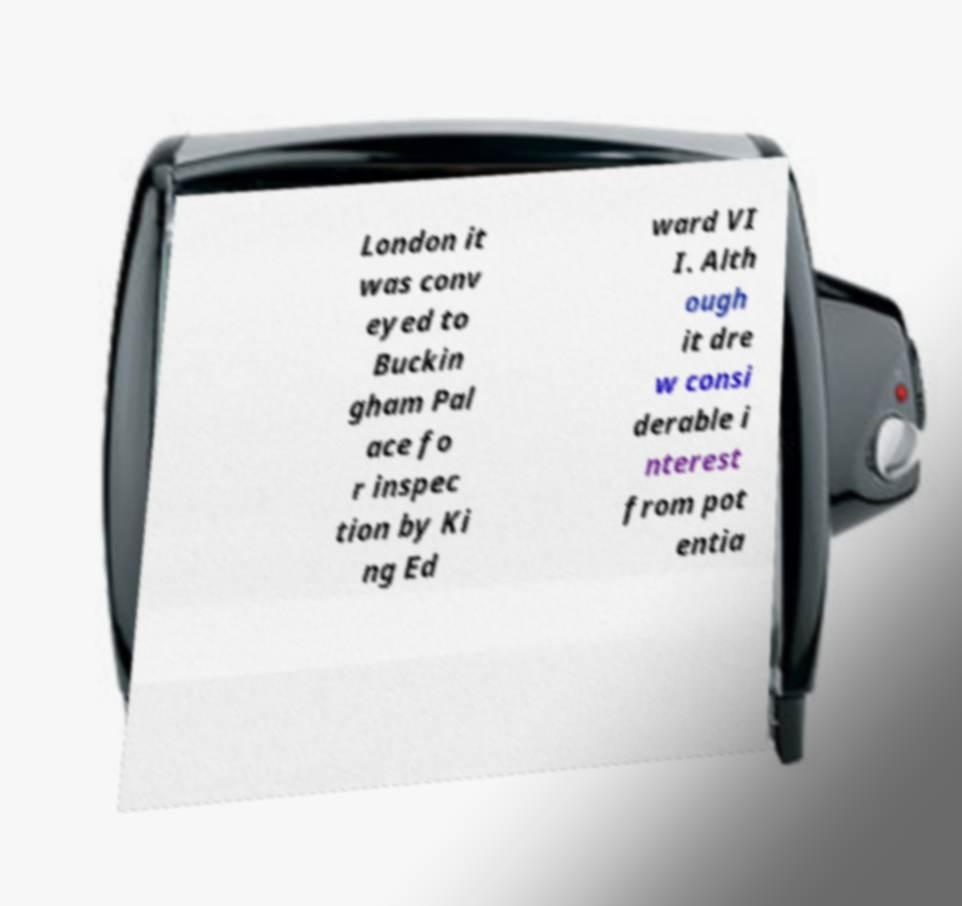Please read and relay the text visible in this image. What does it say? London it was conv eyed to Buckin gham Pal ace fo r inspec tion by Ki ng Ed ward VI I. Alth ough it dre w consi derable i nterest from pot entia 